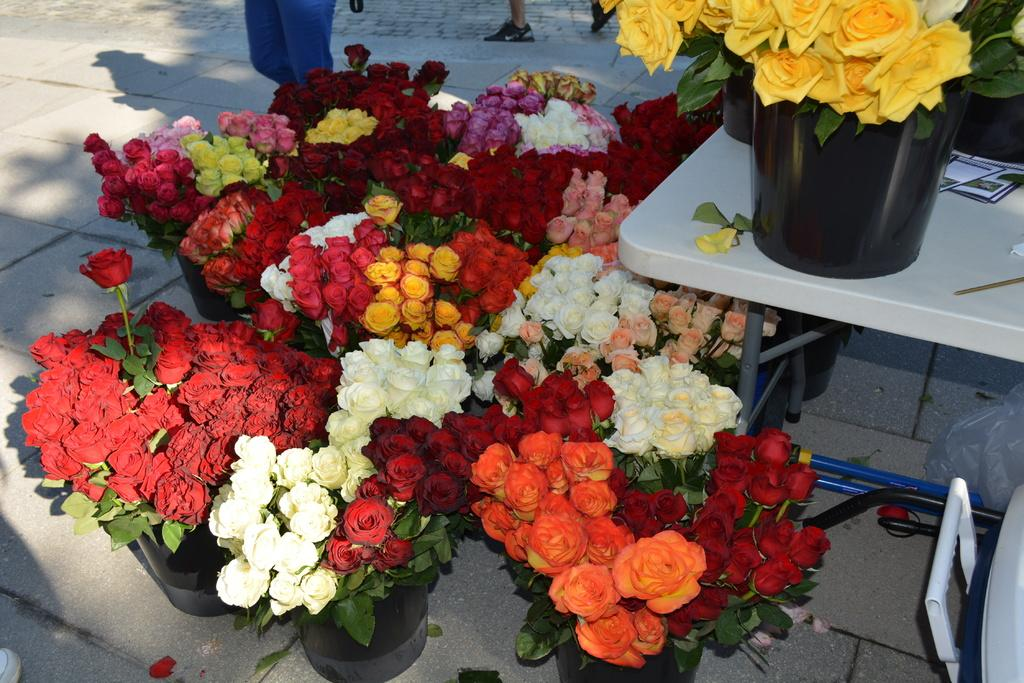What types of flowers can be seen in the image? There are different colors of flowers in the image. What are the flowers placed in? There are pots in the image. What is the main piece of furniture in the image? There is a table in the image. Can you describe any other objects or people in the background? In the background, there are legs of a man visible. Reasoning: Let's think step by step by step in order to produce the conversation. We start by identifying the main subject in the image, which is the flowers. Then, we expand the conversation to include other items that are also visible, such as the pots, table, and the legs of a man in the background. Each question is designed to elicit a specific detail about the image that is known from the provided facts. Absurd Question/Answer: What type of jewel is hanging from the cable in the image? There is no cable or jewel present in the image. What type of shoes is the man wearing in the image? The image only shows the legs of a man, and no shoes are visible. What type of shoes is the man wearing in the image? The image only shows the legs of a man, and no shoes are visible. --- Facts: 1. There is a car in the image. 2. The car is red. 3. The car has four wheels. 4. There is a road in the image. 5. The road is paved. Absurd Topics: bird, ocean, mountain Conversation: What is the main subject of the image? The main subject of the image is a car. What color is the car? The car is red. How many wheels does the car have? The car has four wheels. What type of surface is the car on? There is a road in the image, and it is paved. Reasoning: Let's think step by step in order to produce the conversation. We start by identifying the main subject in the image, which is the car. Then, we describe specific features of the car, such as its color and the number of wheels. Next, we observe the setting in which the car is located, noting that it is on a paved road. Finally, we ensure that the language is simple and clear. Absurd Question/Answer: 